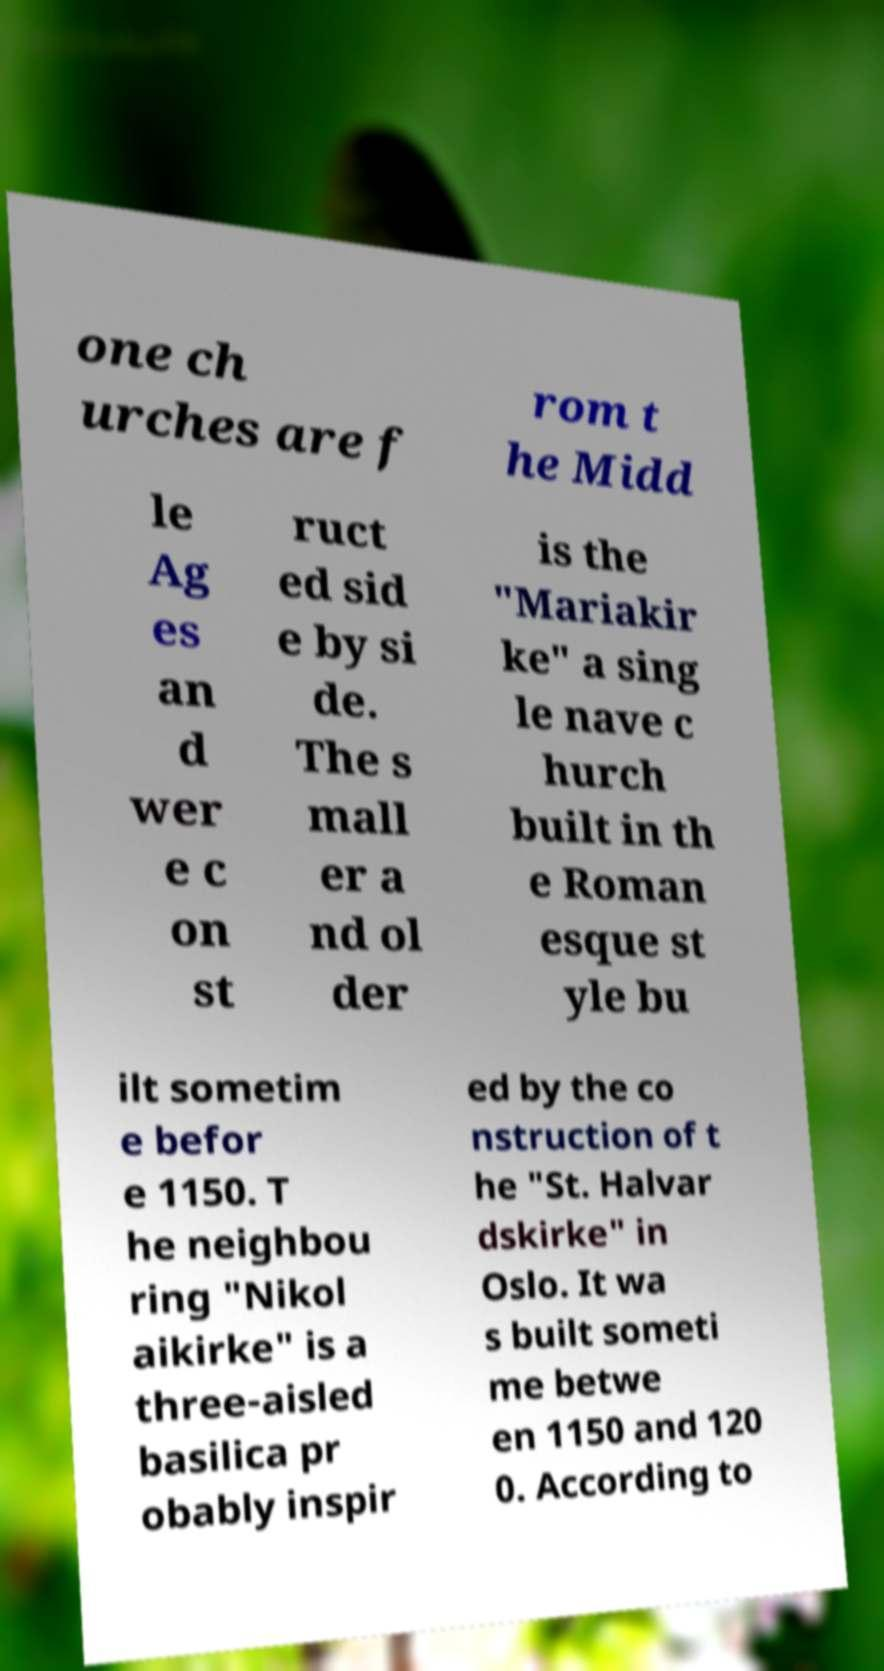What messages or text are displayed in this image? I need them in a readable, typed format. one ch urches are f rom t he Midd le Ag es an d wer e c on st ruct ed sid e by si de. The s mall er a nd ol der is the "Mariakir ke" a sing le nave c hurch built in th e Roman esque st yle bu ilt sometim e befor e 1150. T he neighbou ring "Nikol aikirke" is a three-aisled basilica pr obably inspir ed by the co nstruction of t he "St. Halvar dskirke" in Oslo. It wa s built someti me betwe en 1150 and 120 0. According to 